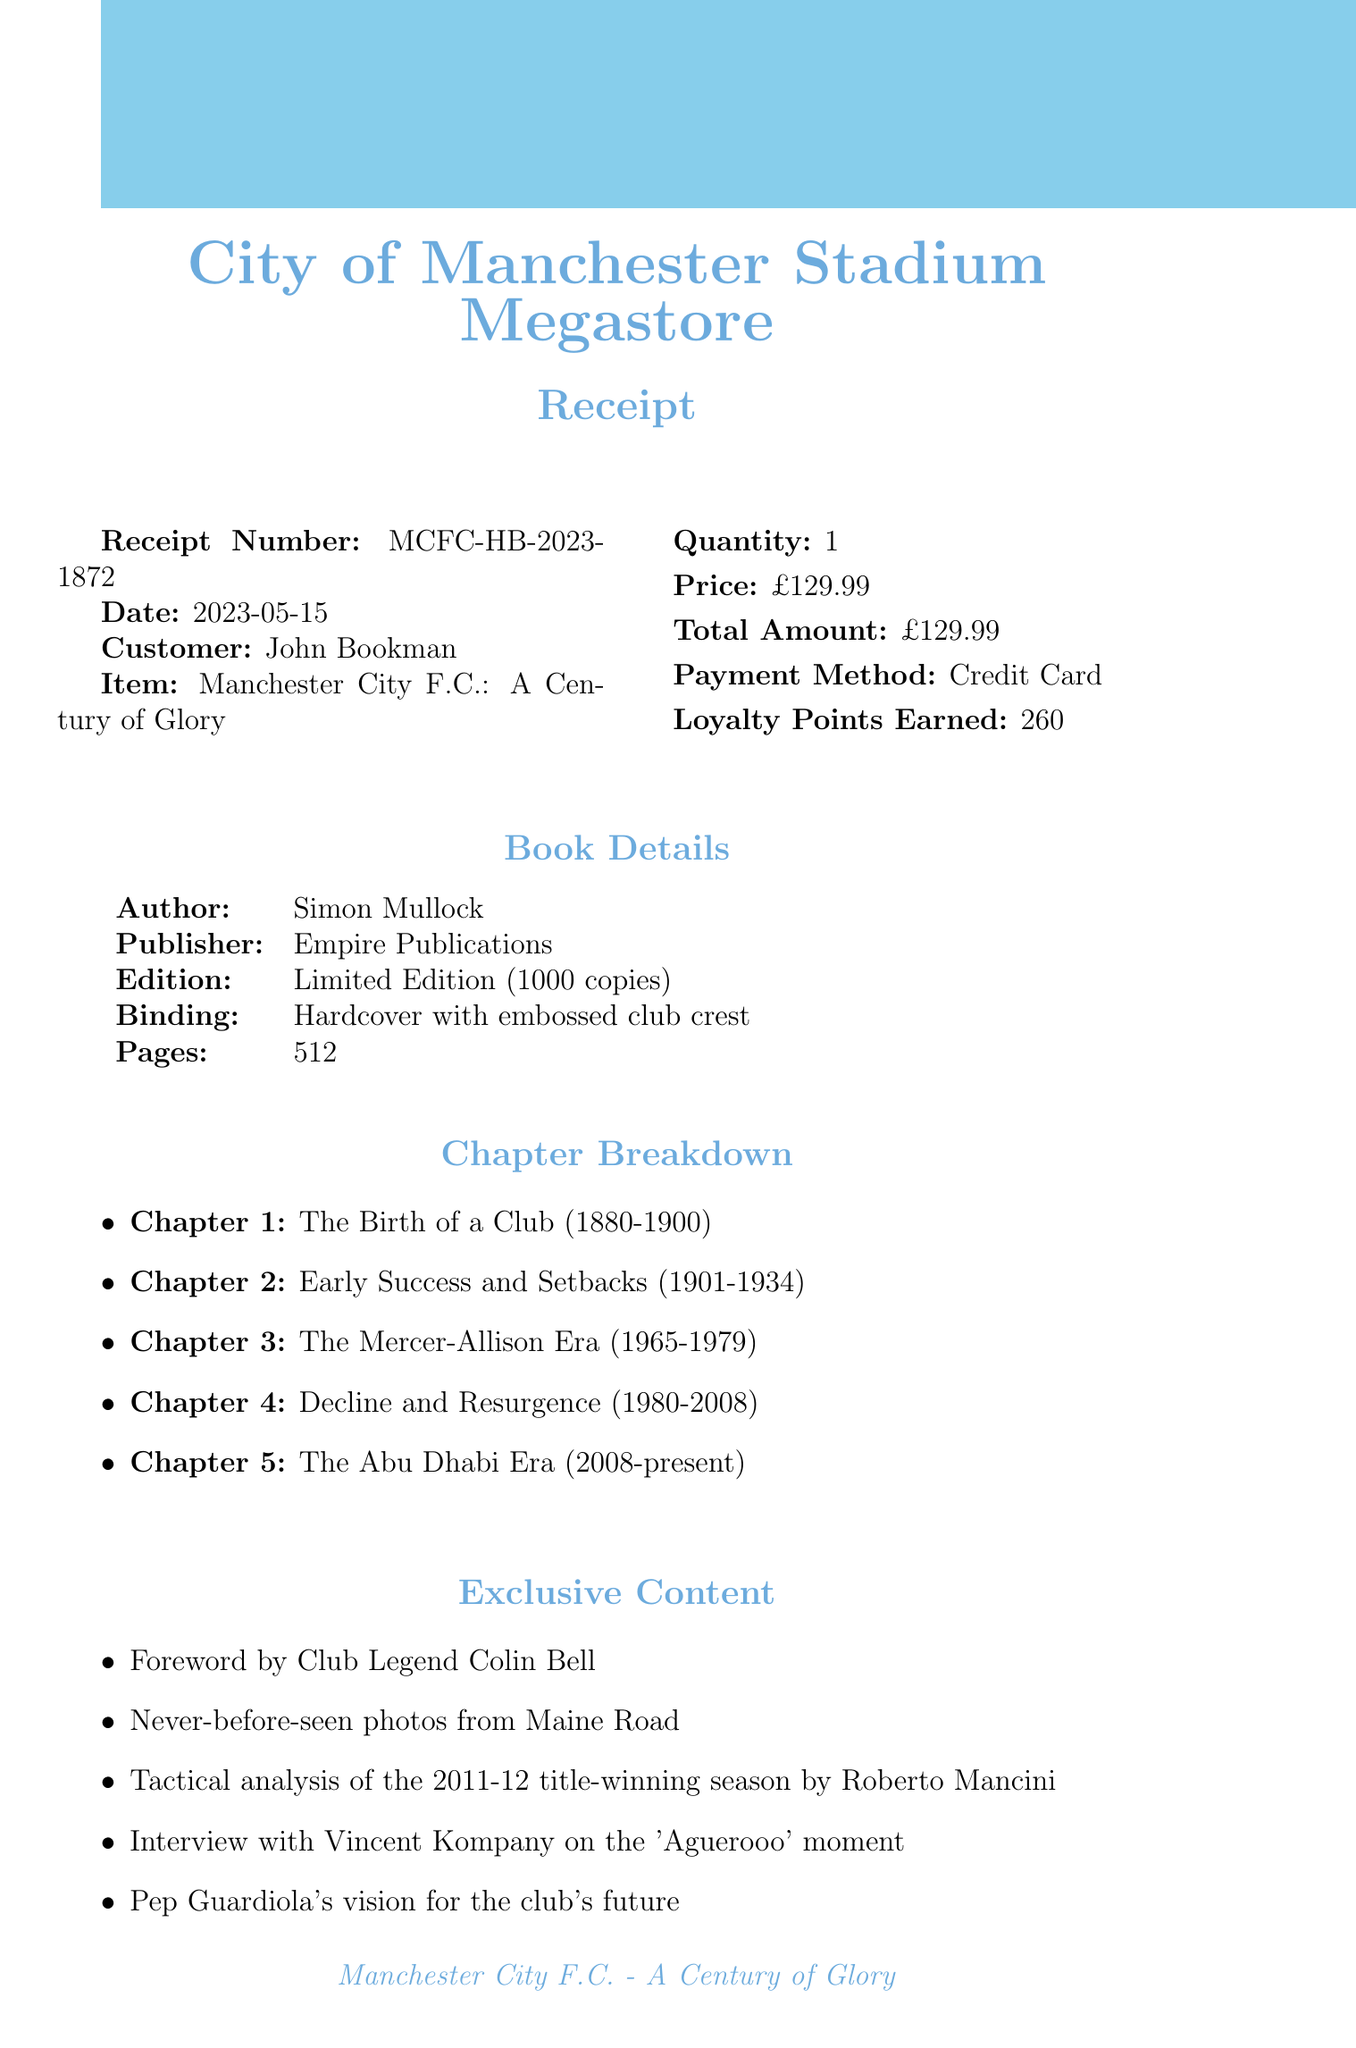What is the receipt number? The receipt number is unique and identifies the transaction. It can be found prominently in the document.
Answer: MCFC-HB-2023-1872 Who is the author of the book? The author name is provided in the book details section of the document.
Answer: Simon Mullock What is the total amount paid? The total amount reflects the cost of the item purchased and is noted in the transaction summary.
Answer: £129.99 What is the edition of the book? The edition describes the exclusivity of the book and is mentioned in the book details.
Answer: Limited Edition (1000 copies) What chapter covers the club's early success and setbacks? This question refers to the chapter titles listed in the breakdown section.
Answer: Chapter 2: Early Success and Setbacks (1901-1934) What special feature includes historical grounds? This question looks for specific content highlighted in the special features section of the document.
Answer: Foldout map of historical City grounds How many loyalty points were earned? Loyalty points represent the rewards earned from the transaction and are clearly displayed.
Answer: 260 What is the next fixture date? The next fixture is mentioned at the end of the document as part of upcoming events.
Answer: 21/05/2023 What type of binding does the book have? The binding type refers to how the book is physically constructed and is listed in the book details.
Answer: Hardcover with embossed club crest 